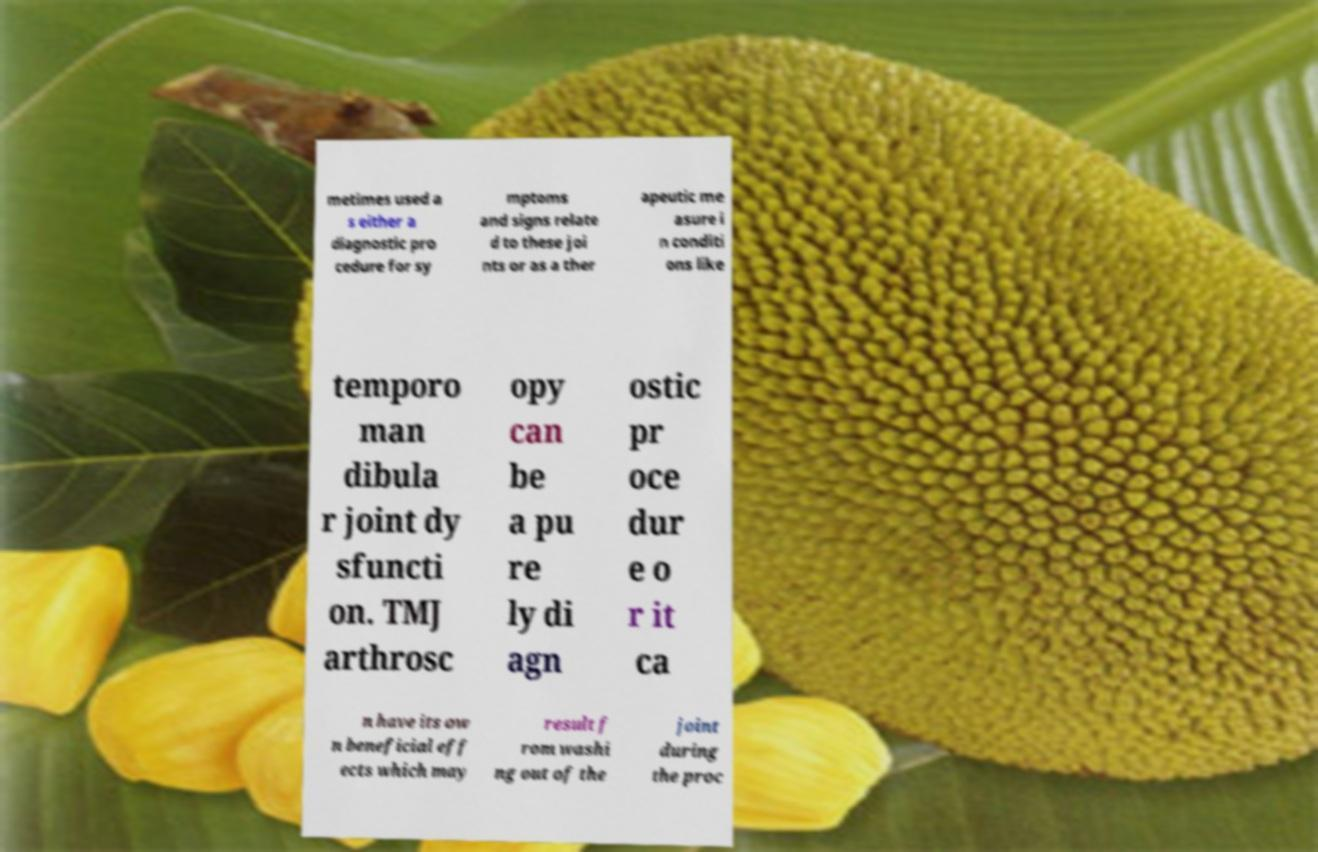What messages or text are displayed in this image? I need them in a readable, typed format. metimes used a s either a diagnostic pro cedure for sy mptoms and signs relate d to these joi nts or as a ther apeutic me asure i n conditi ons like temporo man dibula r joint dy sfuncti on. TMJ arthrosc opy can be a pu re ly di agn ostic pr oce dur e o r it ca n have its ow n beneficial eff ects which may result f rom washi ng out of the joint during the proc 